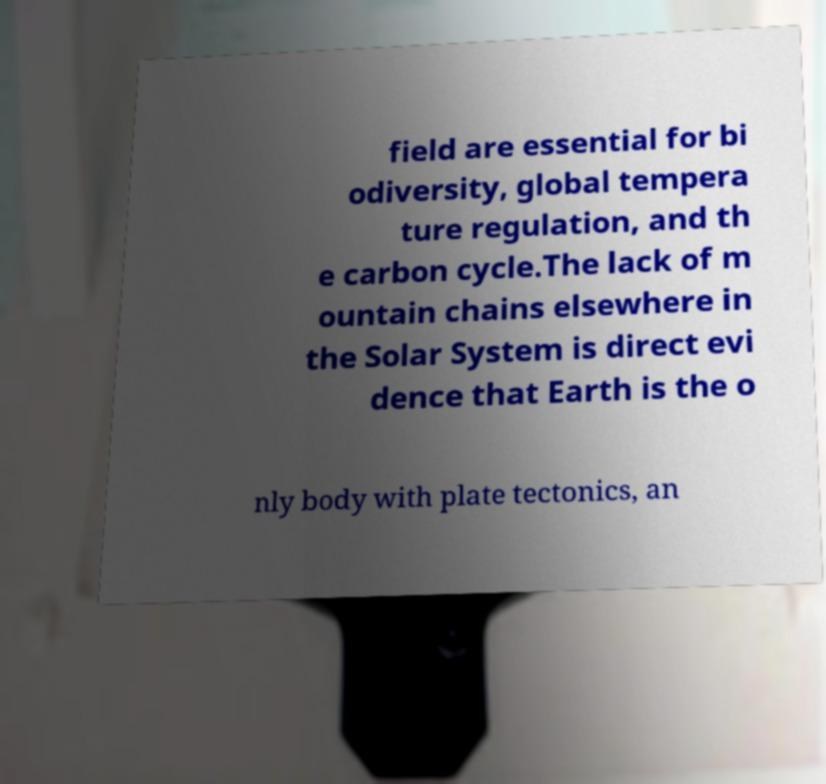Could you extract and type out the text from this image? field are essential for bi odiversity, global tempera ture regulation, and th e carbon cycle.The lack of m ountain chains elsewhere in the Solar System is direct evi dence that Earth is the o nly body with plate tectonics, an 